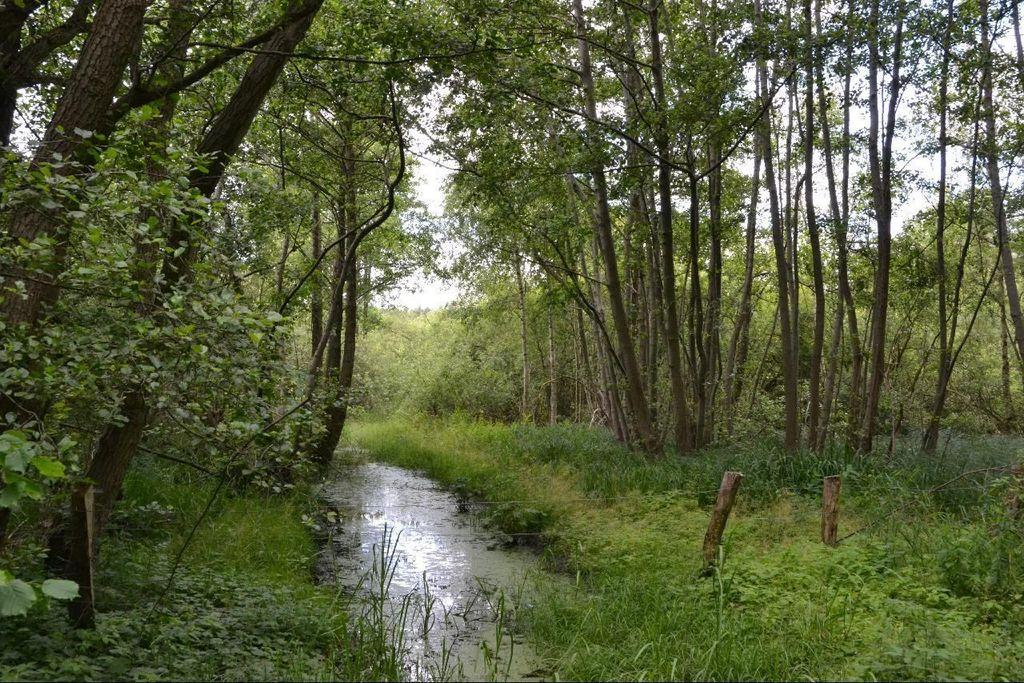What type of vegetation can be seen in the image? There are trees in the image. What part of the natural environment is visible in the image? The sky is visible in the image. What is located between the trees in the image? There is water between the trees. What type of barrier is present in the image? There is fencing in the image. What type of coat is hanging on the steel shop in the image? There is no coat, steel, or shop present in the image. 